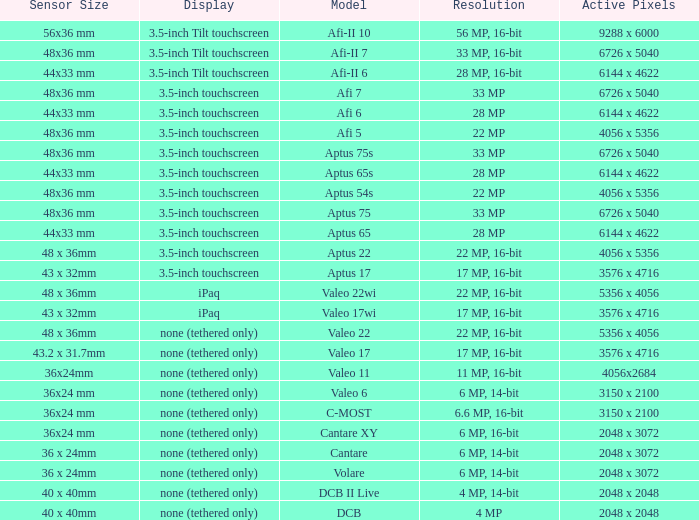Which model is equipped with a sensor measuring 48x36 mm, a pixel count of 6726 x 5040, and a resolution of 33 million pixels? Afi 7, Aptus 75s, Aptus 75. 